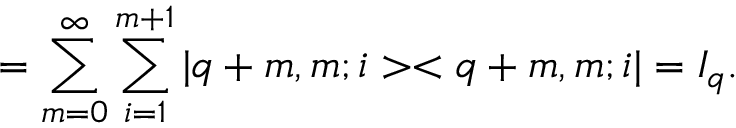Convert formula to latex. <formula><loc_0><loc_0><loc_500><loc_500>= \sum _ { m = 0 } ^ { \infty } \sum _ { i = 1 } ^ { m + 1 } | q + m , m ; i > < q + m , m ; i | = I _ { q } .</formula> 